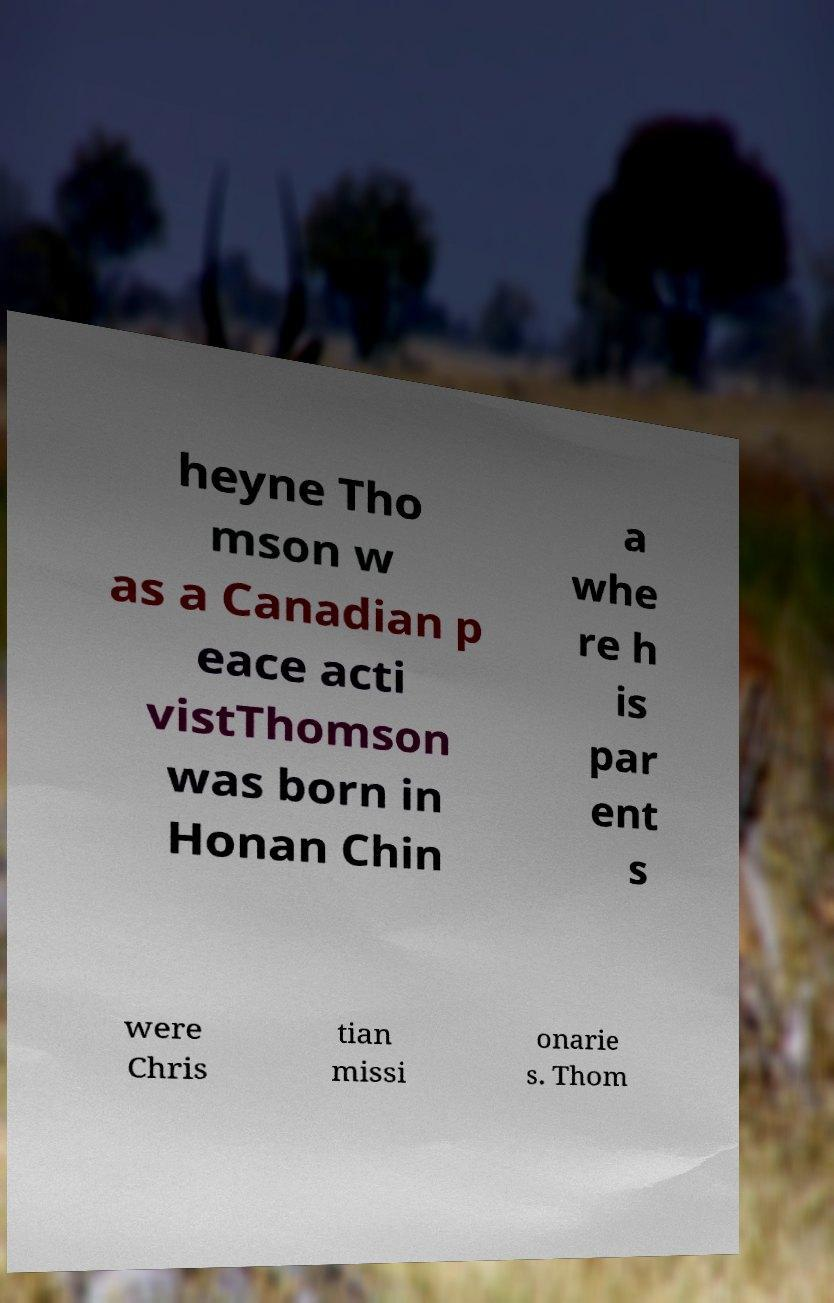Please read and relay the text visible in this image. What does it say? heyne Tho mson w as a Canadian p eace acti vistThomson was born in Honan Chin a whe re h is par ent s were Chris tian missi onarie s. Thom 